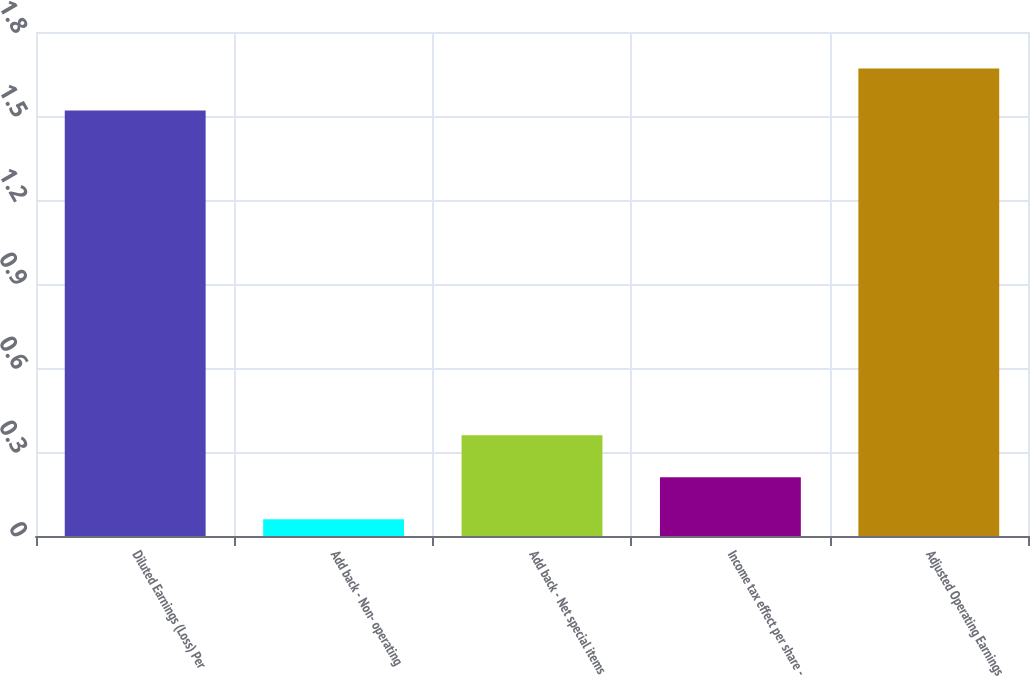<chart> <loc_0><loc_0><loc_500><loc_500><bar_chart><fcel>Diluted Earnings (Loss) Per<fcel>Add back - Non- operating<fcel>Add back - Net special items<fcel>Income tax effect per share -<fcel>Adjusted Operating Earnings<nl><fcel>1.52<fcel>0.06<fcel>0.36<fcel>0.21<fcel>1.67<nl></chart> 